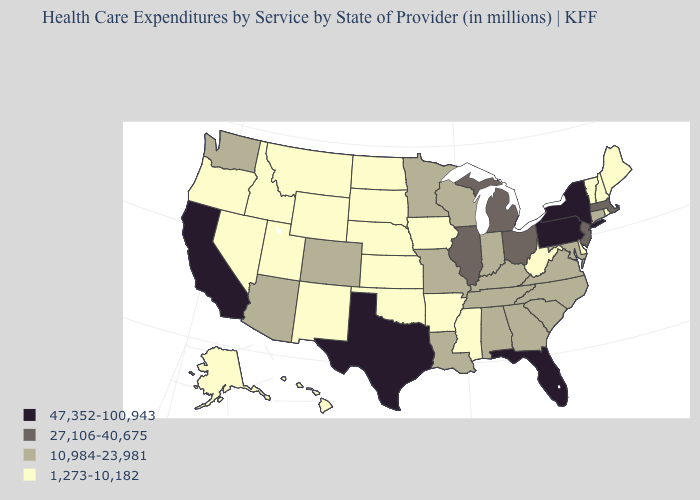Which states hav the highest value in the MidWest?
Write a very short answer. Illinois, Michigan, Ohio. What is the value of Indiana?
Keep it brief. 10,984-23,981. Name the states that have a value in the range 1,273-10,182?
Quick response, please. Alaska, Arkansas, Delaware, Hawaii, Idaho, Iowa, Kansas, Maine, Mississippi, Montana, Nebraska, Nevada, New Hampshire, New Mexico, North Dakota, Oklahoma, Oregon, Rhode Island, South Dakota, Utah, Vermont, West Virginia, Wyoming. What is the value of Louisiana?
Answer briefly. 10,984-23,981. Name the states that have a value in the range 47,352-100,943?
Write a very short answer. California, Florida, New York, Pennsylvania, Texas. Which states have the lowest value in the Northeast?
Be succinct. Maine, New Hampshire, Rhode Island, Vermont. Which states have the lowest value in the USA?
Give a very brief answer. Alaska, Arkansas, Delaware, Hawaii, Idaho, Iowa, Kansas, Maine, Mississippi, Montana, Nebraska, Nevada, New Hampshire, New Mexico, North Dakota, Oklahoma, Oregon, Rhode Island, South Dakota, Utah, Vermont, West Virginia, Wyoming. What is the value of California?
Concise answer only. 47,352-100,943. Is the legend a continuous bar?
Be succinct. No. Name the states that have a value in the range 47,352-100,943?
Short answer required. California, Florida, New York, Pennsylvania, Texas. Name the states that have a value in the range 27,106-40,675?
Short answer required. Illinois, Massachusetts, Michigan, New Jersey, Ohio. How many symbols are there in the legend?
Quick response, please. 4. Which states hav the highest value in the South?
Write a very short answer. Florida, Texas. How many symbols are there in the legend?
Be succinct. 4. Does the first symbol in the legend represent the smallest category?
Keep it brief. No. 